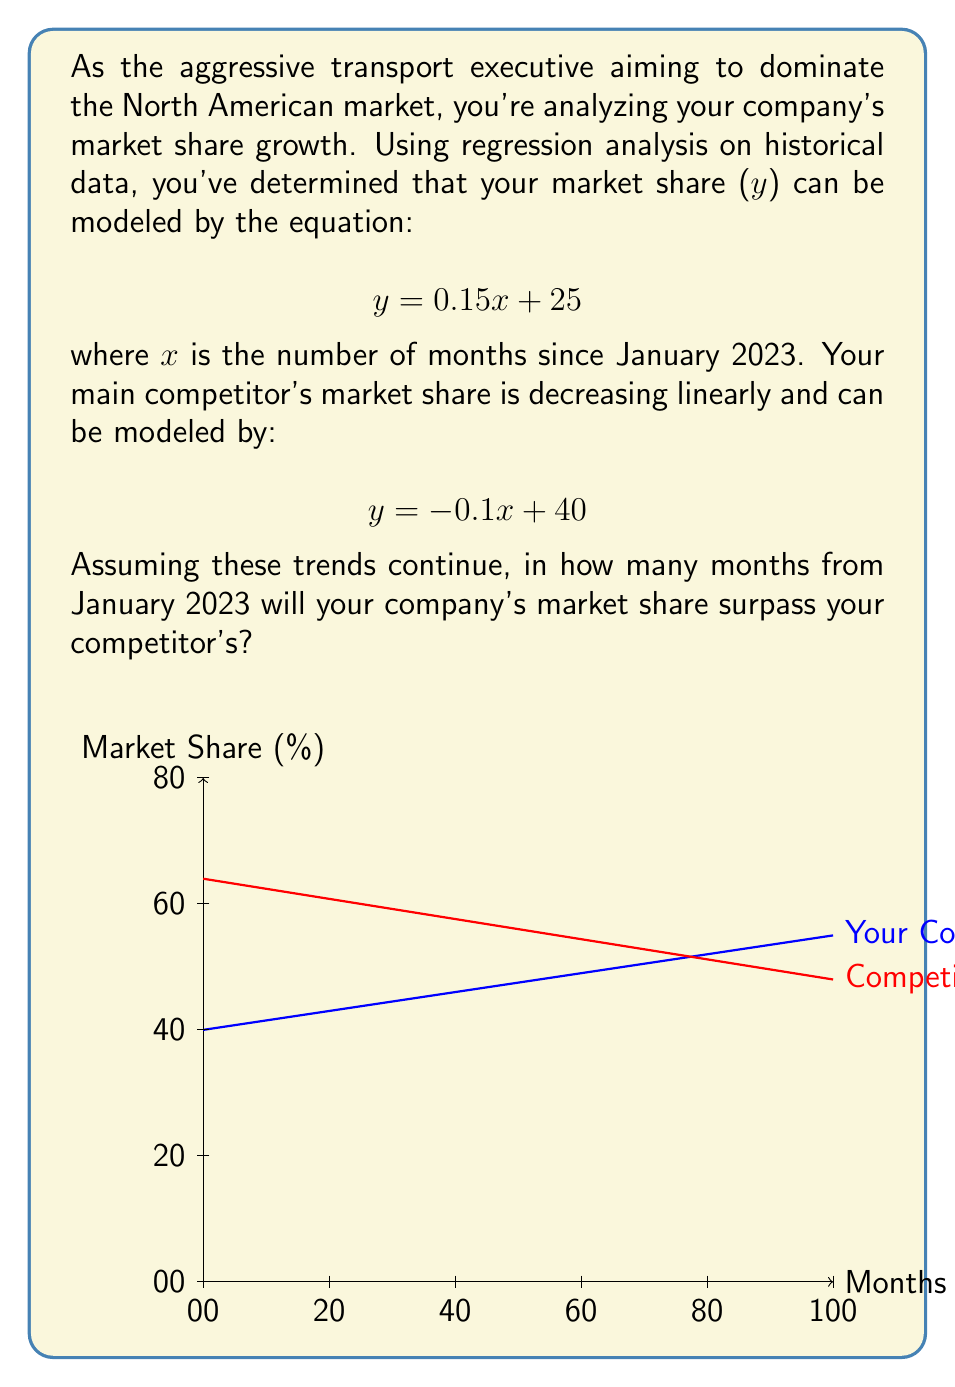What is the answer to this math problem? Let's approach this step-by-step:

1) We need to find the point where the two equations intersect. At this point, both companies will have equal market share.

2) Let's set the equations equal to each other:

   $$ 0.15x + 25 = -0.1x + 40 $$

3) Now, let's solve for x:

   $$ 0.15x + 0.1x = 40 - 25 $$
   $$ 0.25x = 15 $$
   $$ x = 15 / 0.25 = 60 $$

4) The intersection occurs at x = 60 months after January 2023.

5) To verify, we can plug this value back into either equation:

   Your company: $$ y = 0.15(60) + 25 = 34 $$
   Competitor: $$ y = -0.1(60) + 40 = 34 $$

6) Indeed, at 60 months, both companies have a 34% market share.

7) Your company's market share will surpass your competitor's immediately after this point.
Answer: 60 months 